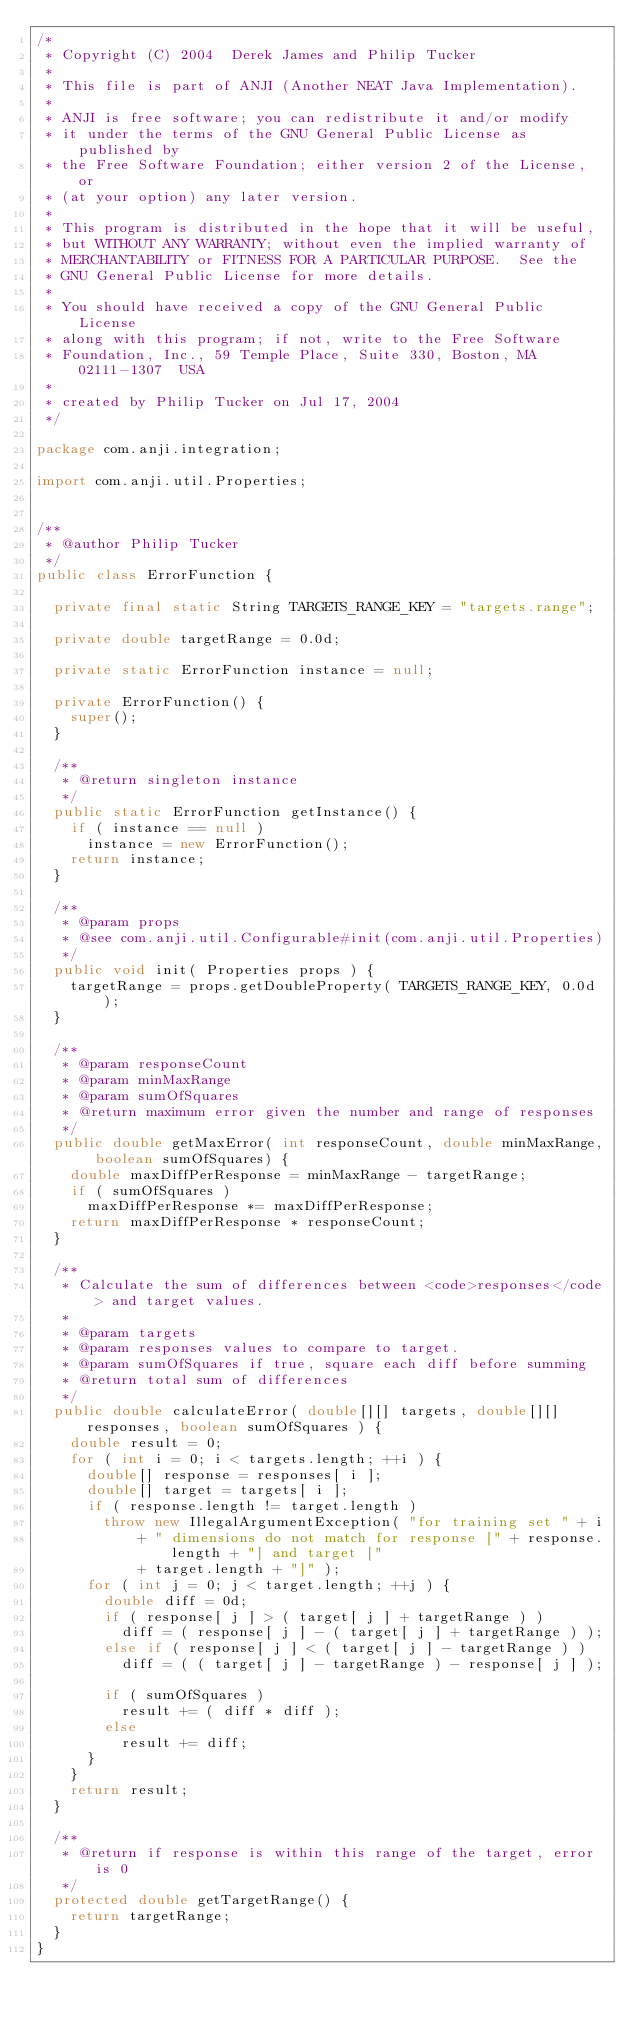<code> <loc_0><loc_0><loc_500><loc_500><_Java_>/*
 * Copyright (C) 2004  Derek James and Philip Tucker
 *
 * This file is part of ANJI (Another NEAT Java Implementation).
 *
 * ANJI is free software; you can redistribute it and/or modify
 * it under the terms of the GNU General Public License as published by
 * the Free Software Foundation; either version 2 of the License, or
 * (at your option) any later version.
 *
 * This program is distributed in the hope that it will be useful,
 * but WITHOUT ANY WARRANTY; without even the implied warranty of
 * MERCHANTABILITY or FITNESS FOR A PARTICULAR PURPOSE.  See the
 * GNU General Public License for more details.
 * 
 * You should have received a copy of the GNU General Public License
 * along with this program; if not, write to the Free Software
 * Foundation, Inc., 59 Temple Place, Suite 330, Boston, MA  02111-1307  USA
 * 
 * created by Philip Tucker on Jul 17, 2004
 */

package com.anji.integration;

import com.anji.util.Properties;


/**
 * @author Philip Tucker
 */
public class ErrorFunction {

	private final static String TARGETS_RANGE_KEY = "targets.range";

	private double targetRange = 0.0d;

	private static ErrorFunction instance = null;
	
	private ErrorFunction() {
		super();
	}

	/**
	 * @return singleton instance
	 */
	public static ErrorFunction getInstance() {
		if ( instance == null )
			instance = new ErrorFunction();
		return instance;
	}
	
	/**
	 * @param props
	 * @see com.anji.util.Configurable#init(com.anji.util.Properties)
	 */
	public void init( Properties props ) {
		targetRange = props.getDoubleProperty( TARGETS_RANGE_KEY, 0.0d );
	}

	/**
	 * @param responseCount
	 * @param minMaxRange
	 * @param sumOfSquares
	 * @return maximum error given the number and range of responses
	 */
	public double getMaxError( int responseCount, double minMaxRange, boolean sumOfSquares) {
		double maxDiffPerResponse = minMaxRange - targetRange;
		if ( sumOfSquares )
			maxDiffPerResponse *= maxDiffPerResponse;
		return maxDiffPerResponse * responseCount;
	}
	
	/**
	 * Calculate the sum of differences between <code>responses</code> and target values.
	 * 
	 * @param targets
	 * @param responses values to compare to target.
	 * @param sumOfSquares if true, square each diff before summing
	 * @return total sum of differences
	 */
	public double calculateError( double[][] targets, double[][] responses, boolean sumOfSquares ) {
		double result = 0;
		for ( int i = 0; i < targets.length; ++i ) {
			double[] response = responses[ i ];
			double[] target = targets[ i ];
			if ( response.length != target.length )
				throw new IllegalArgumentException( "for training set " + i
						+ " dimensions do not match for response [" + response.length + "] and target ["
						+ target.length + "]" );
			for ( int j = 0; j < target.length; ++j ) {
				double diff = 0d;
				if ( response[ j ] > ( target[ j ] + targetRange ) )
					diff = ( response[ j ] - ( target[ j ] + targetRange ) );
				else if ( response[ j ] < ( target[ j ] - targetRange ) )
					diff = ( ( target[ j ] - targetRange ) - response[ j ] );

				if ( sumOfSquares )
					result += ( diff * diff );
				else
					result += diff;
			}
		}
		return result;
	}
	
	/**
	 * @return if response is within this range of the target, error is 0
	 */
	protected double getTargetRange() {
		return targetRange;
	}
}

</code> 